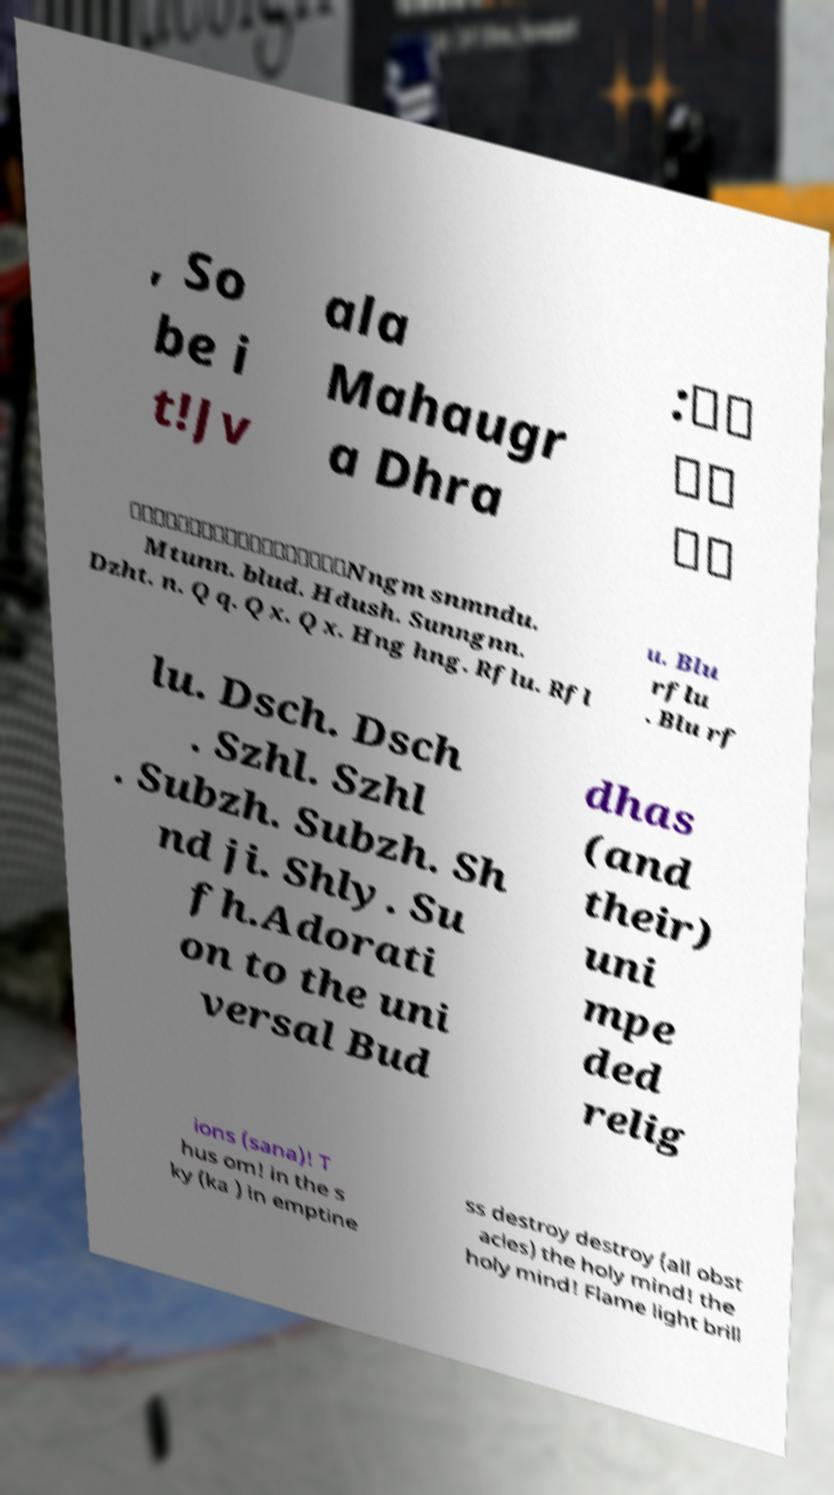There's text embedded in this image that I need extracted. Can you transcribe it verbatim? , So be i t!Jv ala Mahaugr a Dhra :。。 。。 。。 。。。。。。。。。。。。。。。。。。Nngm snmndu. Mtunn. blud. Hdush. Sunngnn. Dzht. n. Q q. Q x. Q x. Hng hng. Rflu. Rfl u. Blu rflu . Blu rf lu. Dsch. Dsch . Szhl. Szhl . Subzh. Subzh. Sh nd ji. Shly. Su fh.Adorati on to the uni versal Bud dhas (and their) uni mpe ded relig ions (sana)! T hus om! in the s ky (ka ) in emptine ss destroy destroy (all obst acles) the holy mind! the holy mind! Flame light brill 